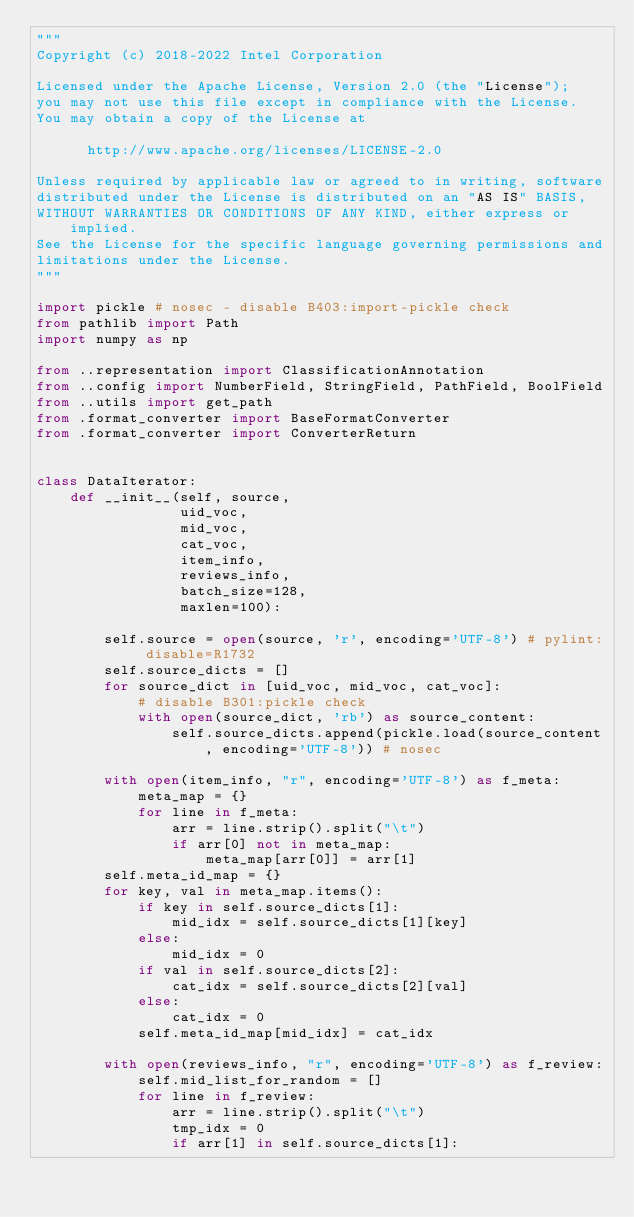Convert code to text. <code><loc_0><loc_0><loc_500><loc_500><_Python_>"""
Copyright (c) 2018-2022 Intel Corporation

Licensed under the Apache License, Version 2.0 (the "License");
you may not use this file except in compliance with the License.
You may obtain a copy of the License at

      http://www.apache.org/licenses/LICENSE-2.0

Unless required by applicable law or agreed to in writing, software
distributed under the License is distributed on an "AS IS" BASIS,
WITHOUT WARRANTIES OR CONDITIONS OF ANY KIND, either express or implied.
See the License for the specific language governing permissions and
limitations under the License.
"""

import pickle # nosec - disable B403:import-pickle check
from pathlib import Path
import numpy as np

from ..representation import ClassificationAnnotation
from ..config import NumberField, StringField, PathField, BoolField
from ..utils import get_path
from .format_converter import BaseFormatConverter
from .format_converter import ConverterReturn


class DataIterator:
    def __init__(self, source,
                 uid_voc,
                 mid_voc,
                 cat_voc,
                 item_info,
                 reviews_info,
                 batch_size=128,
                 maxlen=100):

        self.source = open(source, 'r', encoding='UTF-8') # pylint: disable=R1732
        self.source_dicts = []
        for source_dict in [uid_voc, mid_voc, cat_voc]:
            # disable B301:pickle check
            with open(source_dict, 'rb') as source_content:
                self.source_dicts.append(pickle.load(source_content, encoding='UTF-8')) # nosec

        with open(item_info, "r", encoding='UTF-8') as f_meta:
            meta_map = {}
            for line in f_meta:
                arr = line.strip().split("\t")
                if arr[0] not in meta_map:
                    meta_map[arr[0]] = arr[1]
        self.meta_id_map = {}
        for key, val in meta_map.items():
            if key in self.source_dicts[1]:
                mid_idx = self.source_dicts[1][key]
            else:
                mid_idx = 0
            if val in self.source_dicts[2]:
                cat_idx = self.source_dicts[2][val]
            else:
                cat_idx = 0
            self.meta_id_map[mid_idx] = cat_idx

        with open(reviews_info, "r", encoding='UTF-8') as f_review:
            self.mid_list_for_random = []
            for line in f_review:
                arr = line.strip().split("\t")
                tmp_idx = 0
                if arr[1] in self.source_dicts[1]:</code> 